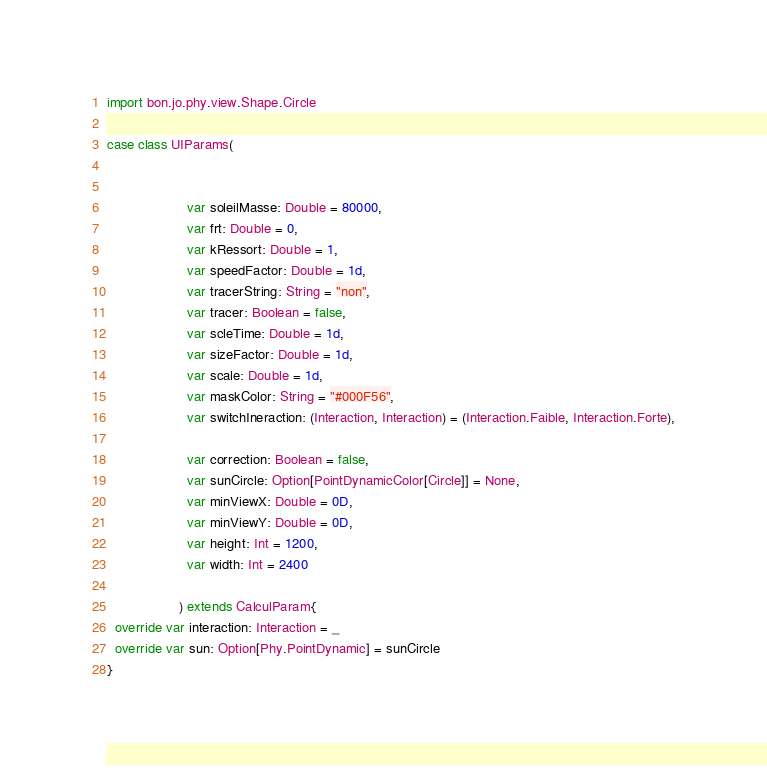Convert code to text. <code><loc_0><loc_0><loc_500><loc_500><_Scala_>import bon.jo.phy.view.Shape.Circle

case class UIParams(


                     var soleilMasse: Double = 80000,
                     var frt: Double = 0,
                     var kRessort: Double = 1,
                     var speedFactor: Double = 1d,
                     var tracerString: String = "non",
                     var tracer: Boolean = false,
                     var scleTime: Double = 1d,
                     var sizeFactor: Double = 1d,
                     var scale: Double = 1d,
                     var maskColor: String = "#000F56",
                     var switchIneraction: (Interaction, Interaction) = (Interaction.Faible, Interaction.Forte),

                     var correction: Boolean = false,
                     var sunCircle: Option[PointDynamicColor[Circle]] = None,
                     var minViewX: Double = 0D,
                     var minViewY: Double = 0D,
                     var height: Int = 1200,
                     var width: Int = 2400

                   ) extends CalculParam{
  override var interaction: Interaction = _
  override var sun: Option[Phy.PointDynamic] = sunCircle
}
</code> 